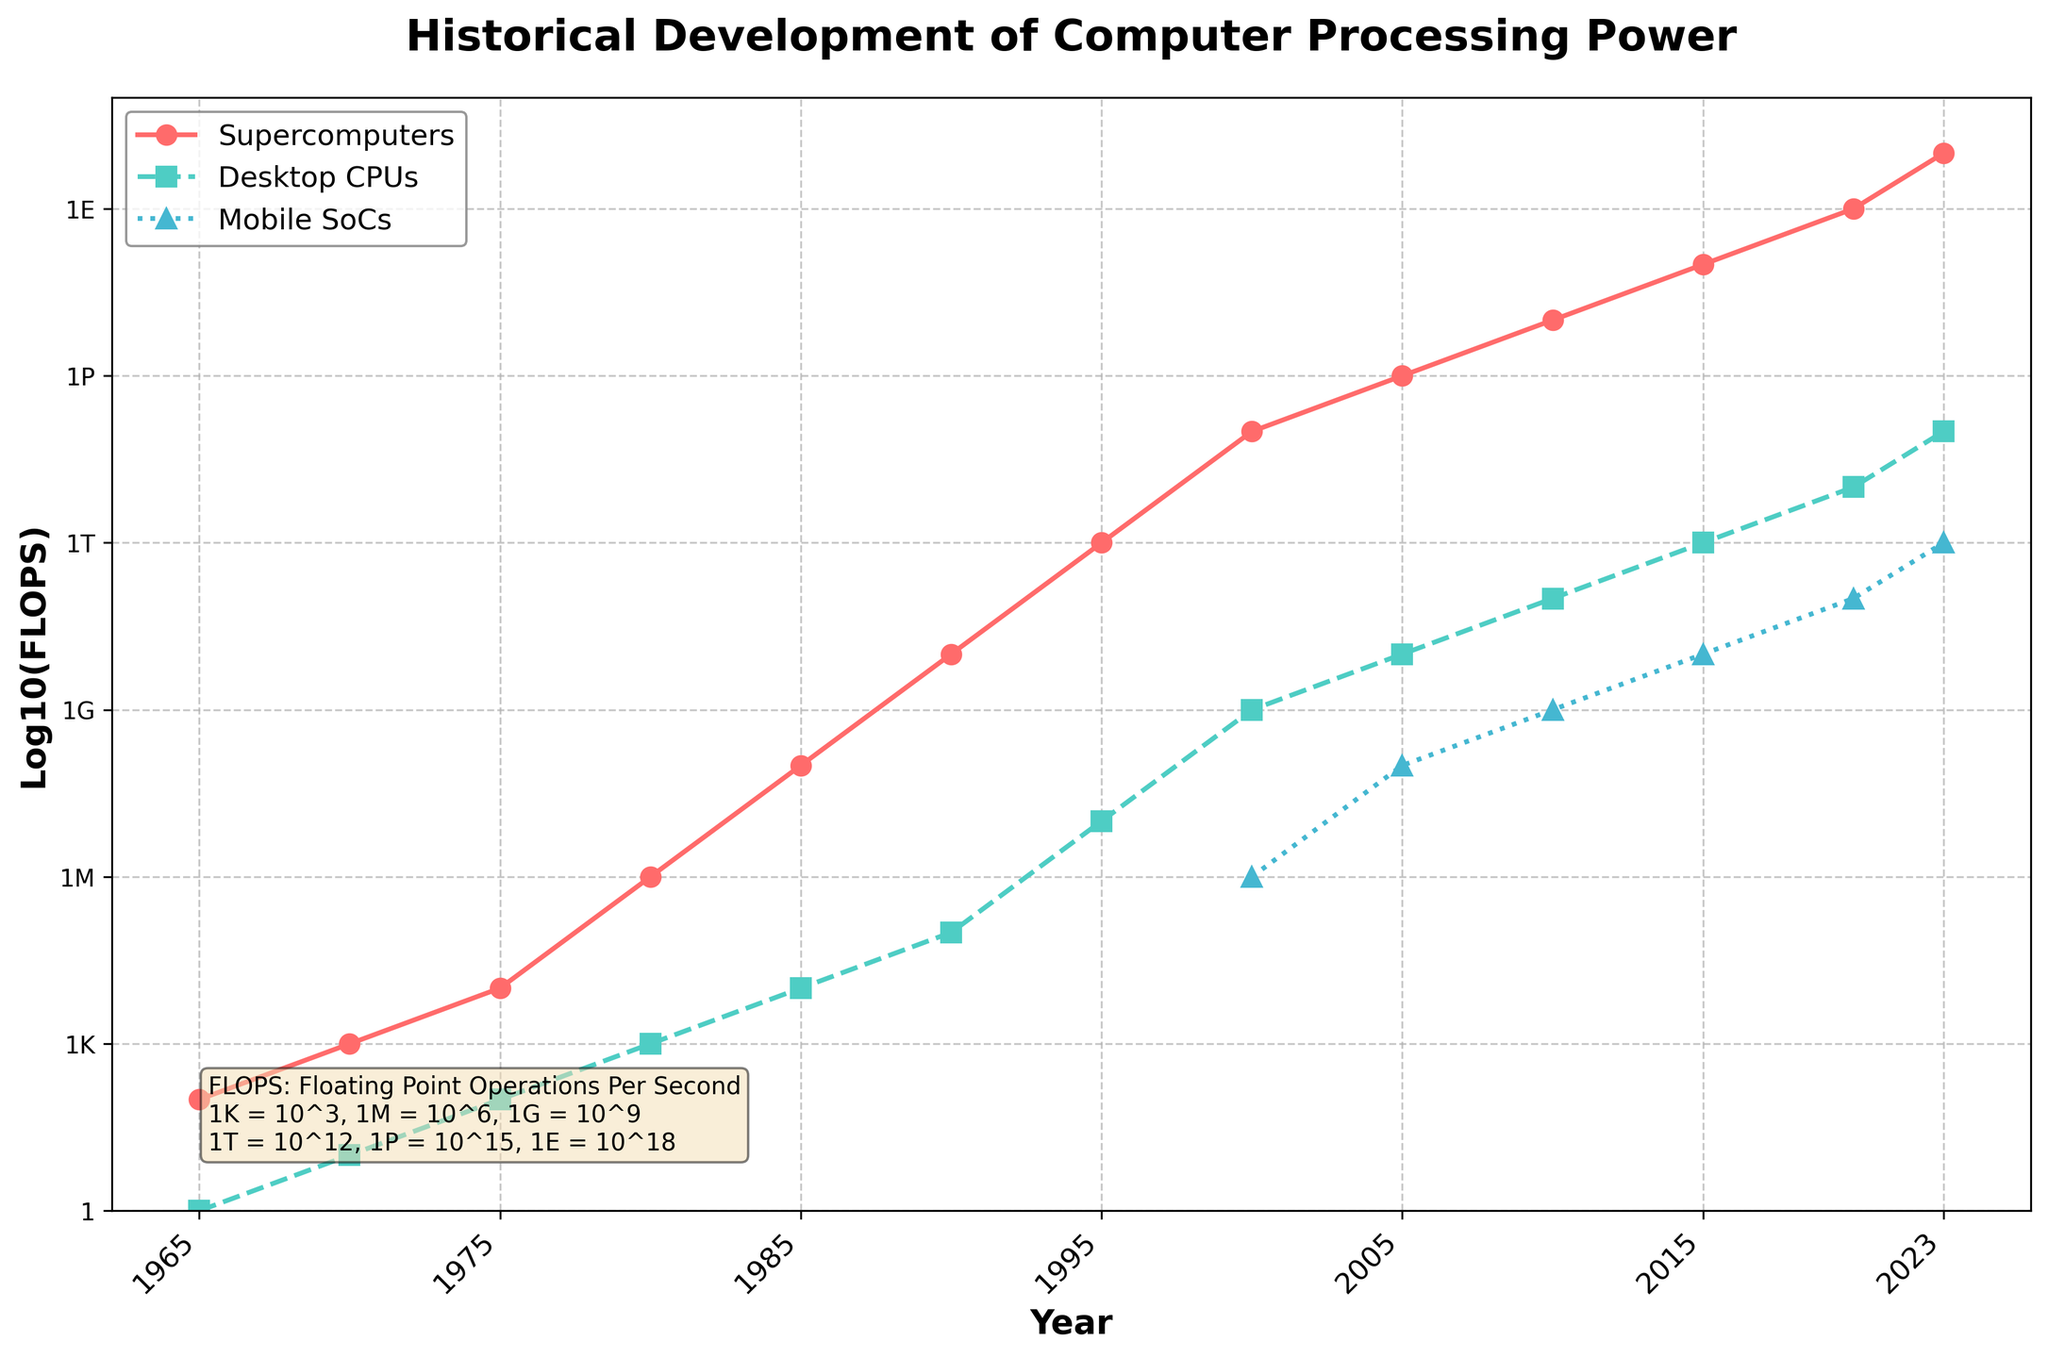What's the trend in the processing power of supercomputers over the years? By examining the data points for supercomputers, we observe that the processing power has steadily increased from 1965 to 2023, with notable increments every five years. The increase can be seen through the upward slope of the red line that represents supercomputers on the plot.
Answer: steadily increasing Between which years did desktop CPUs see the most significant increase in processing power? By examining the green line representing desktop CPUs, the most significant increase appears between 1990 and 1995, where the processing power jumps from around \(10^5\) FLOPS to \(10^7\) FLOPS. This period shows the steepest rise in the line's slope.
Answer: 1990 to 1995 How does the processing power of mobile SoCs in 2020 compare to desktop CPUs in 1995? The blue line representing mobile SoCs in 2020 intersects around \(10^{11}\) FLOPS, while the green line for desktop CPUs in 1995 reaches around \(10^7\) FLOPS. When comparing these values, \(10^{11}\) is significantly higher than \(10^7\).
Answer: mobile SoCs are higher What are the respective FLOPS values for supercomputers, desktop CPUs, and mobile SoCs in the year 2010? In 2010, the red line for supercomputers is at \(10^{16}\) FLOPS, the green line for desktop CPUs is at \(10^{11}\) FLOPS, and the blue line for mobile SoCs is at \(10^9\) FLOPS. The FLOPS values are read directly from the plot at the corresponding year markers.
Answer: \(10^{16}\) FLOPS (supercomputers), \(10^{11}\) FLOPS (desktop CPUs), \(10^9\) FLOPS (mobile SoCs) Which type of processor shows the most rapid initial increase in processing power from 2000 to 2005? Comparing the slopes of the red, green, and blue lines between 2000 and 2005, the supercomputers (red line) show the most rapid initial increase, as it goes from \(10^{14}\) FLOPS in 2000 to \(10^{15}\) FLOPS in 2005. The change is both steep and substantial compared to desktop CPUs and mobile SoCs.
Answer: supercomputers 